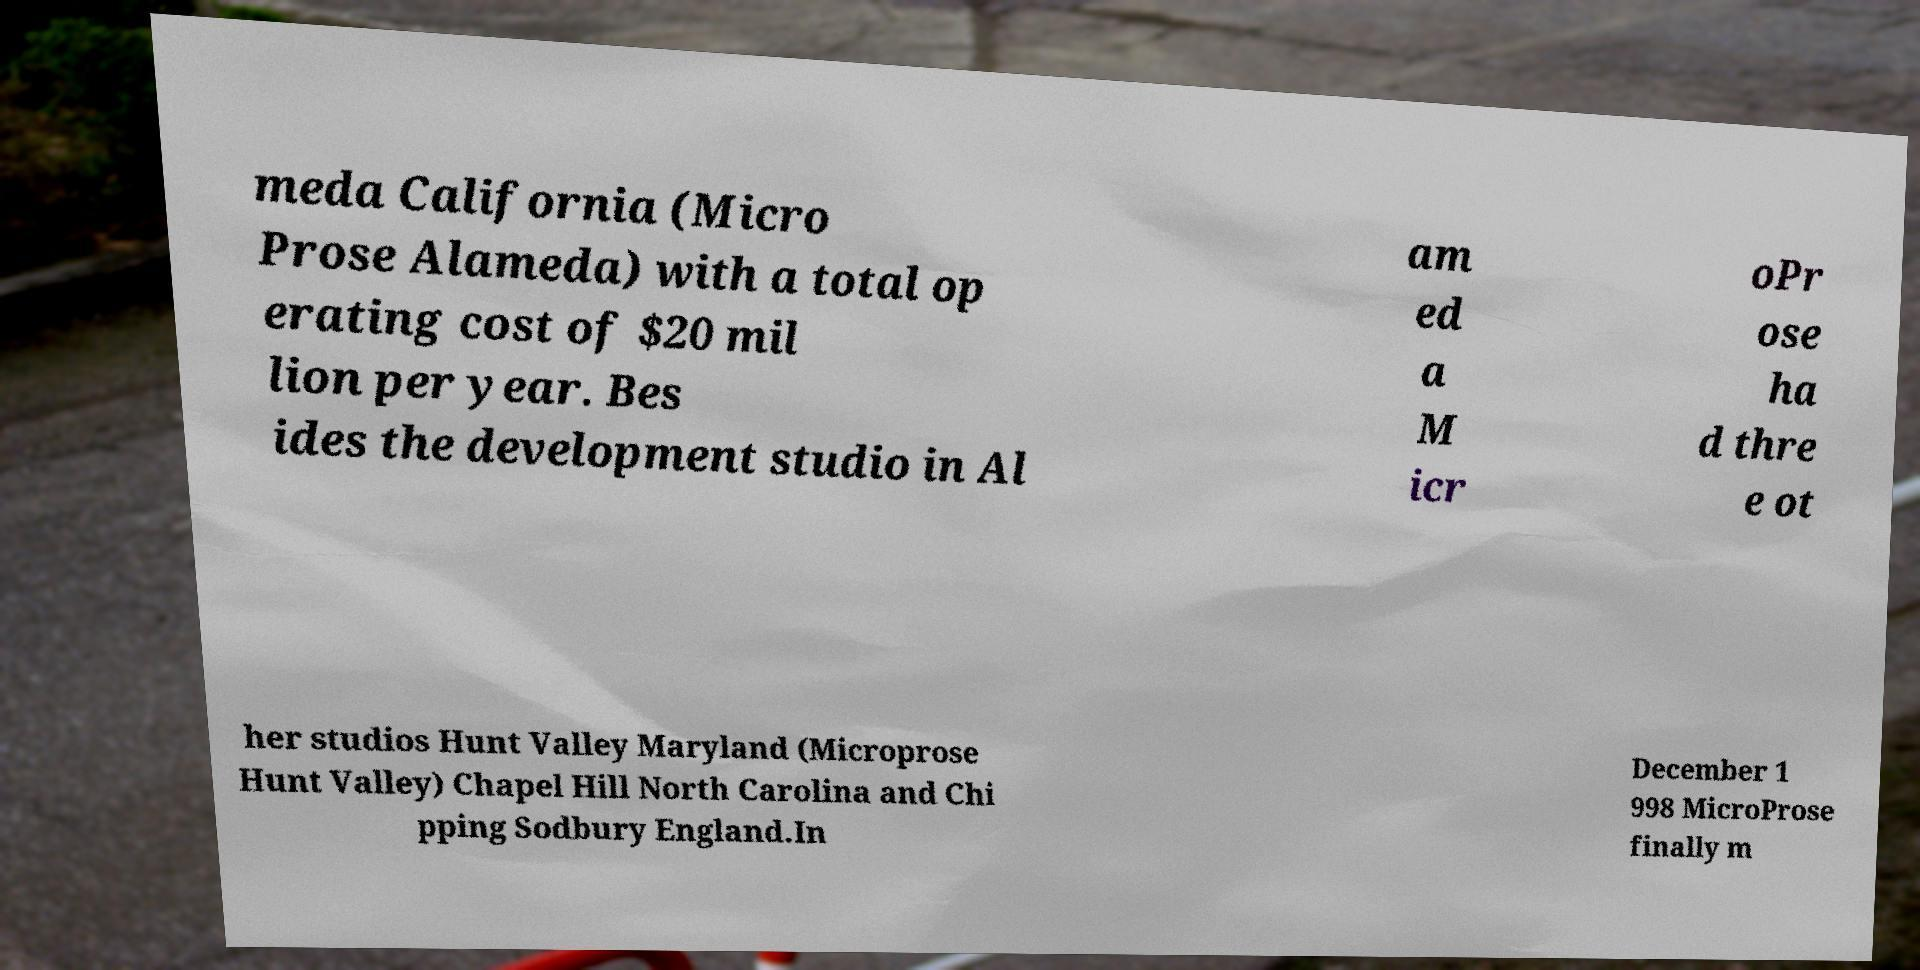For documentation purposes, I need the text within this image transcribed. Could you provide that? meda California (Micro Prose Alameda) with a total op erating cost of $20 mil lion per year. Bes ides the development studio in Al am ed a M icr oPr ose ha d thre e ot her studios Hunt Valley Maryland (Microprose Hunt Valley) Chapel Hill North Carolina and Chi pping Sodbury England.In December 1 998 MicroProse finally m 